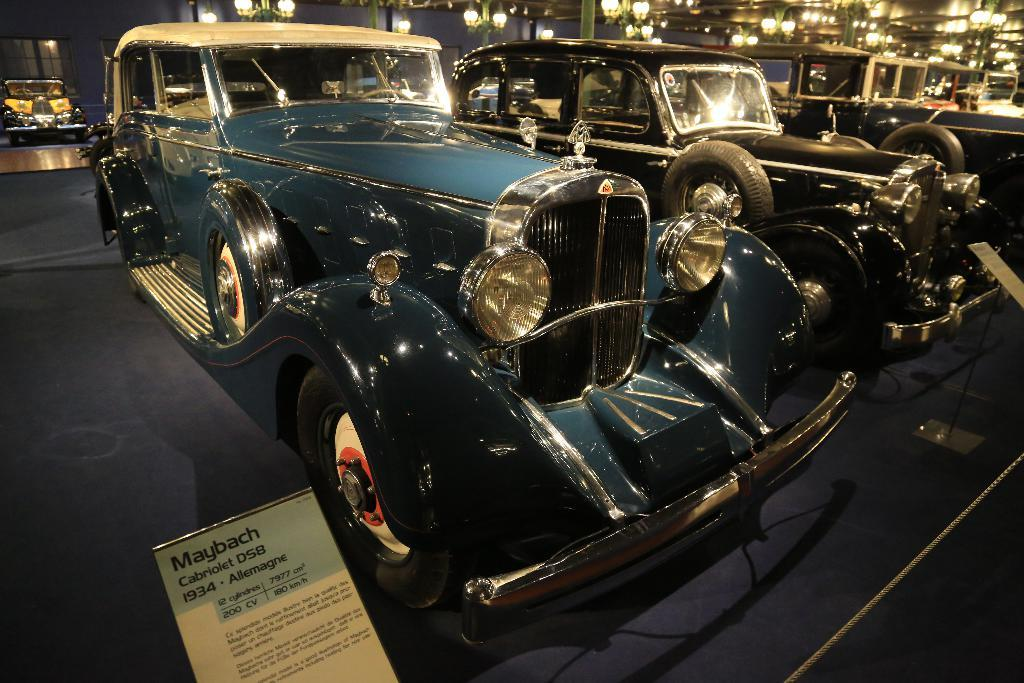What objects are on the floor in the image? There are vehicles on the floor in the image. What structures can be seen in the image? There are poles and a building in the image. What can be used to provide illumination in the image? There are lights in the image. What type of objects have text written on them in the image? There are boards with text in the image. What crime is being committed in the image? There is no crime being committed in the image; it only shows vehicles, poles, lights, boards with text, and a building in the background. 